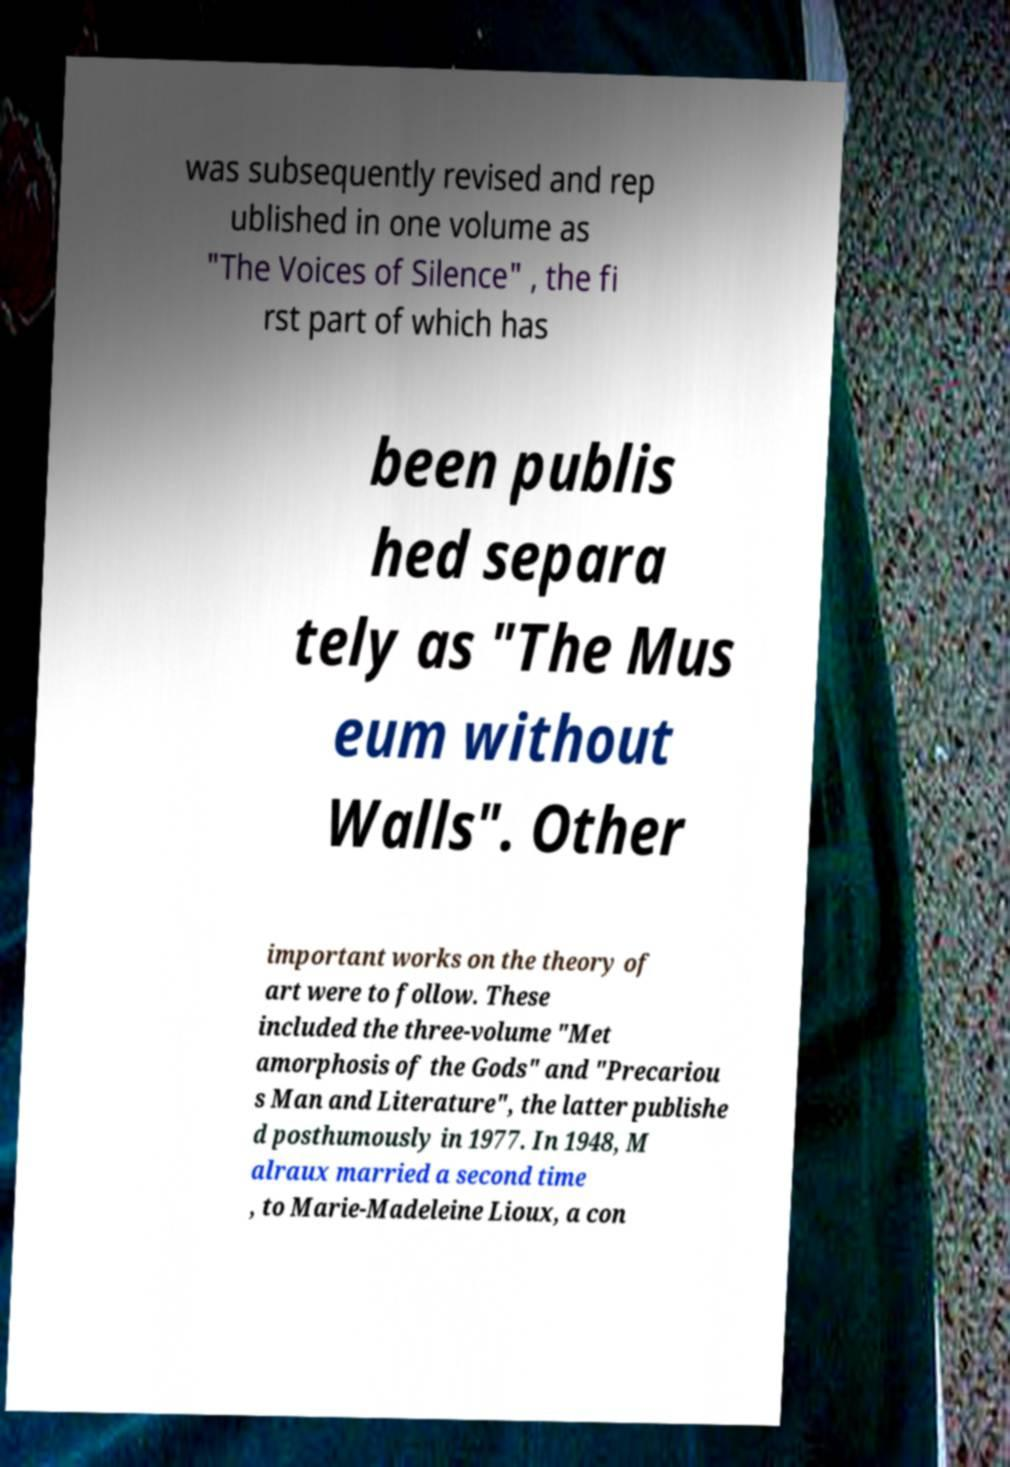Could you assist in decoding the text presented in this image and type it out clearly? was subsequently revised and rep ublished in one volume as "The Voices of Silence" , the fi rst part of which has been publis hed separa tely as "The Mus eum without Walls". Other important works on the theory of art were to follow. These included the three-volume "Met amorphosis of the Gods" and "Precariou s Man and Literature", the latter publishe d posthumously in 1977. In 1948, M alraux married a second time , to Marie-Madeleine Lioux, a con 